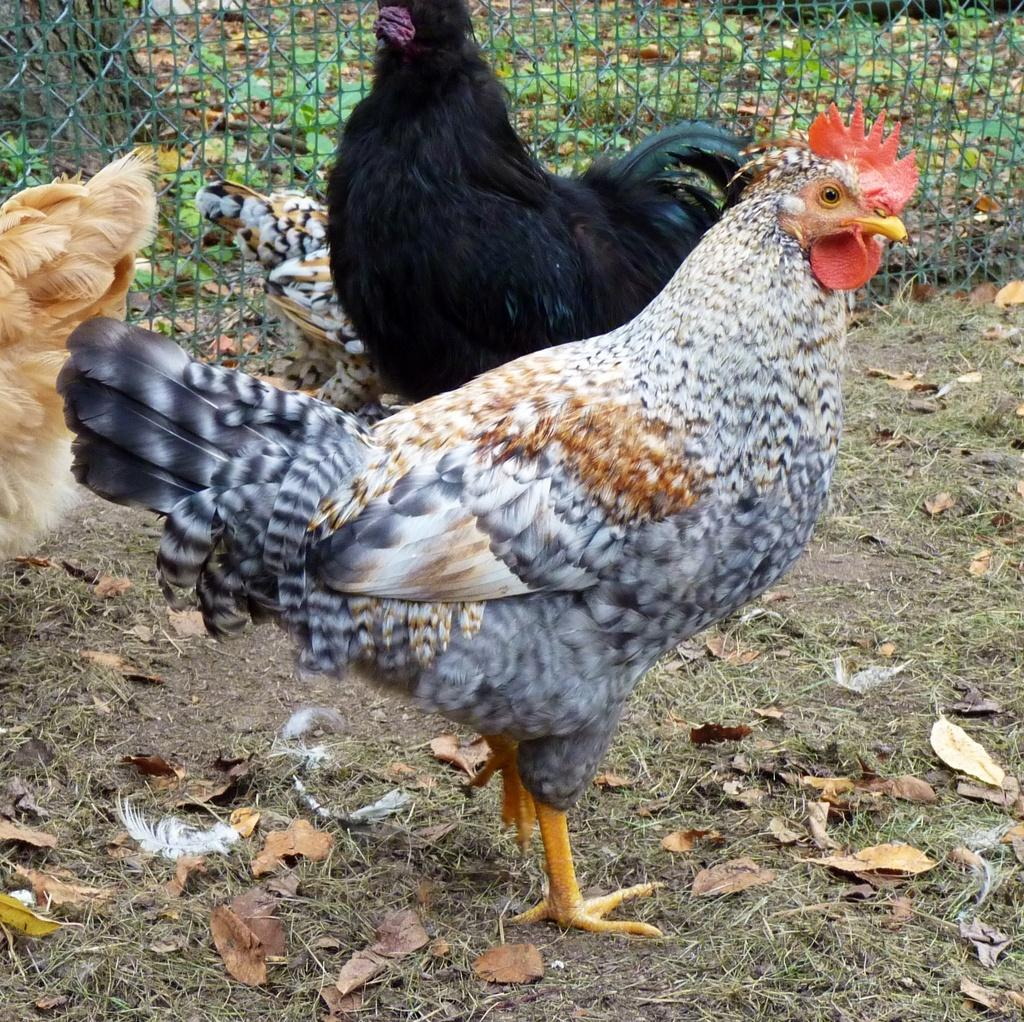What type of animals can be seen in the image? There are hens in the image. What is located at the back of the image? There is a tree at the back of the image. What can be seen behind the fence in the image? There are plants behind the fence in the image. What type of vegetation is present at the bottom of the image? There is grass at the bottom of the image, along with dried leaves and feathers. What type of smell can be detected from the hens in the image? The image does not provide any information about the smell of the hens, so it cannot be determined from the image. 